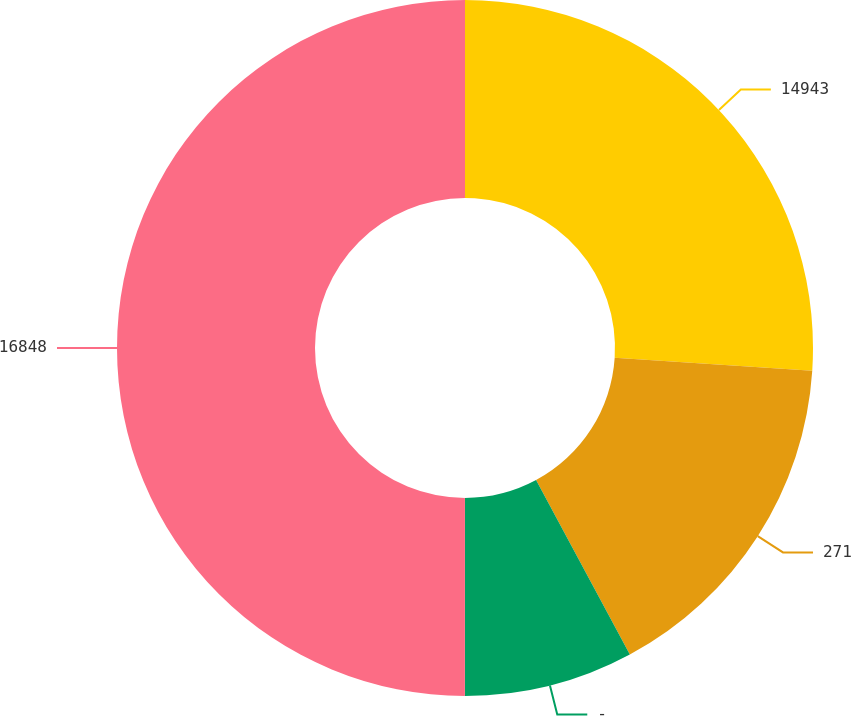Convert chart to OTSL. <chart><loc_0><loc_0><loc_500><loc_500><pie_chart><fcel>14943<fcel>271<fcel>-<fcel>16848<nl><fcel>26.04%<fcel>16.11%<fcel>7.86%<fcel>50.0%<nl></chart> 